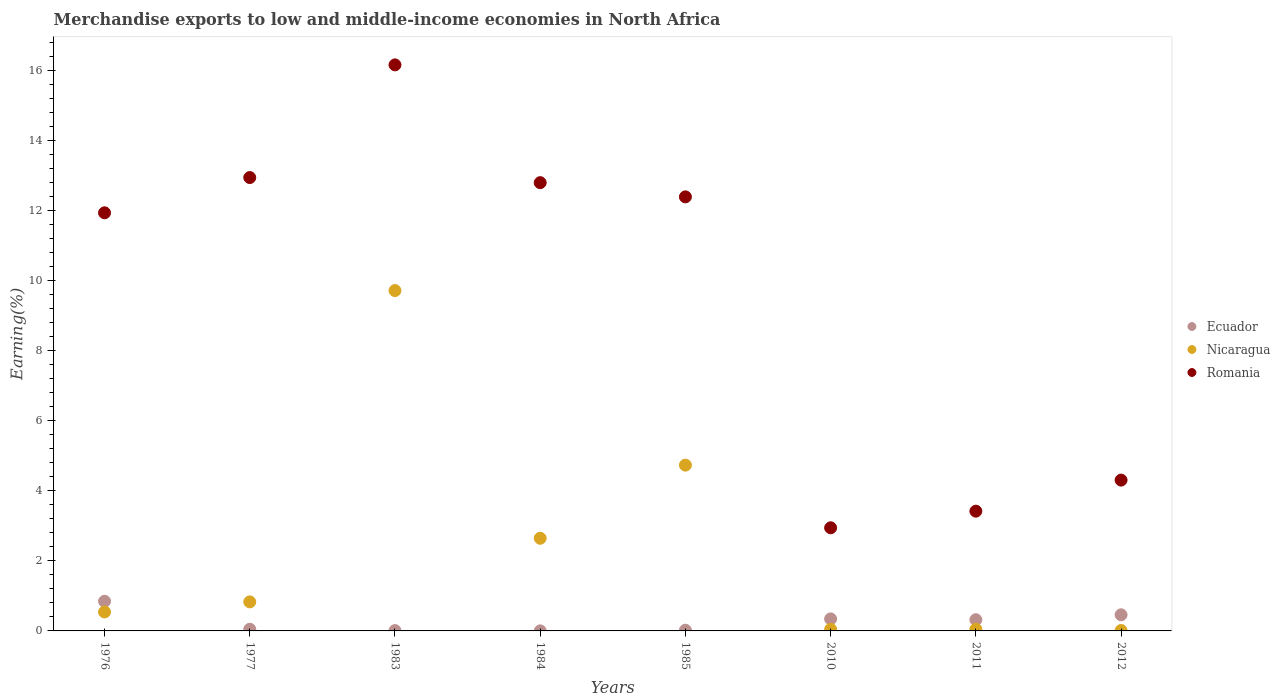What is the percentage of amount earned from merchandise exports in Nicaragua in 1983?
Offer a very short reply. 9.72. Across all years, what is the maximum percentage of amount earned from merchandise exports in Ecuador?
Make the answer very short. 0.85. Across all years, what is the minimum percentage of amount earned from merchandise exports in Ecuador?
Offer a very short reply. 0. In which year was the percentage of amount earned from merchandise exports in Nicaragua maximum?
Offer a very short reply. 1983. What is the total percentage of amount earned from merchandise exports in Romania in the graph?
Offer a terse response. 76.9. What is the difference between the percentage of amount earned from merchandise exports in Nicaragua in 1976 and that in 2012?
Your answer should be very brief. 0.53. What is the difference between the percentage of amount earned from merchandise exports in Ecuador in 1983 and the percentage of amount earned from merchandise exports in Romania in 2010?
Offer a very short reply. -2.94. What is the average percentage of amount earned from merchandise exports in Nicaragua per year?
Your answer should be compact. 2.32. In the year 1976, what is the difference between the percentage of amount earned from merchandise exports in Nicaragua and percentage of amount earned from merchandise exports in Romania?
Give a very brief answer. -11.4. What is the ratio of the percentage of amount earned from merchandise exports in Romania in 1984 to that in 2012?
Offer a very short reply. 2.97. Is the difference between the percentage of amount earned from merchandise exports in Nicaragua in 1976 and 1984 greater than the difference between the percentage of amount earned from merchandise exports in Romania in 1976 and 1984?
Make the answer very short. No. What is the difference between the highest and the second highest percentage of amount earned from merchandise exports in Romania?
Provide a short and direct response. 3.22. What is the difference between the highest and the lowest percentage of amount earned from merchandise exports in Ecuador?
Your answer should be compact. 0.84. Does the percentage of amount earned from merchandise exports in Ecuador monotonically increase over the years?
Your answer should be very brief. No. Is the percentage of amount earned from merchandise exports in Ecuador strictly greater than the percentage of amount earned from merchandise exports in Romania over the years?
Provide a succinct answer. No. Is the percentage of amount earned from merchandise exports in Ecuador strictly less than the percentage of amount earned from merchandise exports in Nicaragua over the years?
Your answer should be very brief. No. How are the legend labels stacked?
Your response must be concise. Vertical. What is the title of the graph?
Keep it short and to the point. Merchandise exports to low and middle-income economies in North Africa. Does "New Zealand" appear as one of the legend labels in the graph?
Provide a short and direct response. No. What is the label or title of the X-axis?
Ensure brevity in your answer.  Years. What is the label or title of the Y-axis?
Keep it short and to the point. Earning(%). What is the Earning(%) in Ecuador in 1976?
Your response must be concise. 0.85. What is the Earning(%) of Nicaragua in 1976?
Provide a short and direct response. 0.54. What is the Earning(%) in Romania in 1976?
Provide a succinct answer. 11.94. What is the Earning(%) in Ecuador in 1977?
Your answer should be compact. 0.05. What is the Earning(%) in Nicaragua in 1977?
Provide a succinct answer. 0.83. What is the Earning(%) in Romania in 1977?
Make the answer very short. 12.94. What is the Earning(%) of Ecuador in 1983?
Your answer should be compact. 0.01. What is the Earning(%) of Nicaragua in 1983?
Offer a terse response. 9.72. What is the Earning(%) of Romania in 1983?
Provide a short and direct response. 16.16. What is the Earning(%) of Ecuador in 1984?
Make the answer very short. 0. What is the Earning(%) of Nicaragua in 1984?
Offer a very short reply. 2.65. What is the Earning(%) of Romania in 1984?
Provide a succinct answer. 12.8. What is the Earning(%) of Ecuador in 1985?
Keep it short and to the point. 0.02. What is the Earning(%) in Nicaragua in 1985?
Offer a terse response. 4.73. What is the Earning(%) in Romania in 1985?
Provide a short and direct response. 12.39. What is the Earning(%) in Ecuador in 2010?
Give a very brief answer. 0.34. What is the Earning(%) of Nicaragua in 2010?
Your response must be concise. 0.05. What is the Earning(%) in Romania in 2010?
Offer a very short reply. 2.94. What is the Earning(%) of Ecuador in 2011?
Give a very brief answer. 0.32. What is the Earning(%) of Nicaragua in 2011?
Make the answer very short. 0.05. What is the Earning(%) in Romania in 2011?
Your answer should be very brief. 3.42. What is the Earning(%) in Ecuador in 2012?
Your response must be concise. 0.46. What is the Earning(%) of Nicaragua in 2012?
Make the answer very short. 0.01. What is the Earning(%) of Romania in 2012?
Offer a terse response. 4.31. Across all years, what is the maximum Earning(%) in Ecuador?
Your answer should be compact. 0.85. Across all years, what is the maximum Earning(%) of Nicaragua?
Your response must be concise. 9.72. Across all years, what is the maximum Earning(%) of Romania?
Offer a very short reply. 16.16. Across all years, what is the minimum Earning(%) of Ecuador?
Give a very brief answer. 0. Across all years, what is the minimum Earning(%) in Nicaragua?
Keep it short and to the point. 0.01. Across all years, what is the minimum Earning(%) in Romania?
Provide a short and direct response. 2.94. What is the total Earning(%) of Ecuador in the graph?
Provide a succinct answer. 2.05. What is the total Earning(%) in Nicaragua in the graph?
Provide a short and direct response. 18.57. What is the total Earning(%) of Romania in the graph?
Your answer should be very brief. 76.9. What is the difference between the Earning(%) of Ecuador in 1976 and that in 1977?
Your response must be concise. 0.8. What is the difference between the Earning(%) of Nicaragua in 1976 and that in 1977?
Provide a succinct answer. -0.29. What is the difference between the Earning(%) in Romania in 1976 and that in 1977?
Your answer should be compact. -1.01. What is the difference between the Earning(%) in Ecuador in 1976 and that in 1983?
Provide a succinct answer. 0.84. What is the difference between the Earning(%) of Nicaragua in 1976 and that in 1983?
Offer a very short reply. -9.18. What is the difference between the Earning(%) of Romania in 1976 and that in 1983?
Your response must be concise. -4.22. What is the difference between the Earning(%) in Ecuador in 1976 and that in 1984?
Your answer should be compact. 0.84. What is the difference between the Earning(%) of Nicaragua in 1976 and that in 1984?
Your answer should be very brief. -2.1. What is the difference between the Earning(%) in Romania in 1976 and that in 1984?
Offer a very short reply. -0.86. What is the difference between the Earning(%) of Ecuador in 1976 and that in 1985?
Your answer should be compact. 0.83. What is the difference between the Earning(%) of Nicaragua in 1976 and that in 1985?
Ensure brevity in your answer.  -4.19. What is the difference between the Earning(%) of Romania in 1976 and that in 1985?
Your response must be concise. -0.46. What is the difference between the Earning(%) in Ecuador in 1976 and that in 2010?
Provide a short and direct response. 0.5. What is the difference between the Earning(%) in Nicaragua in 1976 and that in 2010?
Your answer should be very brief. 0.5. What is the difference between the Earning(%) in Romania in 1976 and that in 2010?
Offer a very short reply. 8.99. What is the difference between the Earning(%) of Ecuador in 1976 and that in 2011?
Your answer should be compact. 0.53. What is the difference between the Earning(%) of Nicaragua in 1976 and that in 2011?
Ensure brevity in your answer.  0.49. What is the difference between the Earning(%) in Romania in 1976 and that in 2011?
Keep it short and to the point. 8.52. What is the difference between the Earning(%) of Ecuador in 1976 and that in 2012?
Give a very brief answer. 0.39. What is the difference between the Earning(%) in Nicaragua in 1976 and that in 2012?
Ensure brevity in your answer.  0.53. What is the difference between the Earning(%) in Romania in 1976 and that in 2012?
Provide a short and direct response. 7.63. What is the difference between the Earning(%) of Ecuador in 1977 and that in 1983?
Offer a terse response. 0.04. What is the difference between the Earning(%) of Nicaragua in 1977 and that in 1983?
Your answer should be very brief. -8.89. What is the difference between the Earning(%) in Romania in 1977 and that in 1983?
Make the answer very short. -3.22. What is the difference between the Earning(%) of Ecuador in 1977 and that in 1984?
Give a very brief answer. 0.05. What is the difference between the Earning(%) in Nicaragua in 1977 and that in 1984?
Ensure brevity in your answer.  -1.82. What is the difference between the Earning(%) of Romania in 1977 and that in 1984?
Give a very brief answer. 0.15. What is the difference between the Earning(%) of Ecuador in 1977 and that in 1985?
Provide a succinct answer. 0.03. What is the difference between the Earning(%) in Nicaragua in 1977 and that in 1985?
Provide a short and direct response. -3.9. What is the difference between the Earning(%) of Romania in 1977 and that in 1985?
Provide a short and direct response. 0.55. What is the difference between the Earning(%) of Ecuador in 1977 and that in 2010?
Your response must be concise. -0.29. What is the difference between the Earning(%) of Nicaragua in 1977 and that in 2010?
Your answer should be compact. 0.78. What is the difference between the Earning(%) in Romania in 1977 and that in 2010?
Provide a short and direct response. 10. What is the difference between the Earning(%) in Ecuador in 1977 and that in 2011?
Provide a succinct answer. -0.27. What is the difference between the Earning(%) in Nicaragua in 1977 and that in 2011?
Provide a short and direct response. 0.78. What is the difference between the Earning(%) of Romania in 1977 and that in 2011?
Provide a short and direct response. 9.52. What is the difference between the Earning(%) in Ecuador in 1977 and that in 2012?
Make the answer very short. -0.41. What is the difference between the Earning(%) of Nicaragua in 1977 and that in 2012?
Ensure brevity in your answer.  0.82. What is the difference between the Earning(%) of Romania in 1977 and that in 2012?
Keep it short and to the point. 8.64. What is the difference between the Earning(%) in Ecuador in 1983 and that in 1984?
Ensure brevity in your answer.  0.01. What is the difference between the Earning(%) of Nicaragua in 1983 and that in 1984?
Provide a short and direct response. 7.07. What is the difference between the Earning(%) in Romania in 1983 and that in 1984?
Ensure brevity in your answer.  3.36. What is the difference between the Earning(%) of Ecuador in 1983 and that in 1985?
Offer a terse response. -0.01. What is the difference between the Earning(%) in Nicaragua in 1983 and that in 1985?
Ensure brevity in your answer.  4.98. What is the difference between the Earning(%) in Romania in 1983 and that in 1985?
Your response must be concise. 3.77. What is the difference between the Earning(%) of Ecuador in 1983 and that in 2010?
Keep it short and to the point. -0.33. What is the difference between the Earning(%) in Nicaragua in 1983 and that in 2010?
Provide a short and direct response. 9.67. What is the difference between the Earning(%) of Romania in 1983 and that in 2010?
Provide a succinct answer. 13.22. What is the difference between the Earning(%) in Ecuador in 1983 and that in 2011?
Make the answer very short. -0.31. What is the difference between the Earning(%) of Nicaragua in 1983 and that in 2011?
Provide a succinct answer. 9.67. What is the difference between the Earning(%) in Romania in 1983 and that in 2011?
Make the answer very short. 12.74. What is the difference between the Earning(%) in Ecuador in 1983 and that in 2012?
Keep it short and to the point. -0.45. What is the difference between the Earning(%) of Nicaragua in 1983 and that in 2012?
Provide a short and direct response. 9.71. What is the difference between the Earning(%) in Romania in 1983 and that in 2012?
Ensure brevity in your answer.  11.85. What is the difference between the Earning(%) in Ecuador in 1984 and that in 1985?
Your answer should be compact. -0.02. What is the difference between the Earning(%) of Nicaragua in 1984 and that in 1985?
Ensure brevity in your answer.  -2.09. What is the difference between the Earning(%) in Romania in 1984 and that in 1985?
Offer a terse response. 0.41. What is the difference between the Earning(%) of Ecuador in 1984 and that in 2010?
Provide a short and direct response. -0.34. What is the difference between the Earning(%) of Romania in 1984 and that in 2010?
Your answer should be very brief. 9.85. What is the difference between the Earning(%) in Ecuador in 1984 and that in 2011?
Your response must be concise. -0.32. What is the difference between the Earning(%) in Nicaragua in 1984 and that in 2011?
Your response must be concise. 2.6. What is the difference between the Earning(%) in Romania in 1984 and that in 2011?
Provide a short and direct response. 9.38. What is the difference between the Earning(%) in Ecuador in 1984 and that in 2012?
Your answer should be very brief. -0.46. What is the difference between the Earning(%) of Nicaragua in 1984 and that in 2012?
Your response must be concise. 2.63. What is the difference between the Earning(%) in Romania in 1984 and that in 2012?
Provide a short and direct response. 8.49. What is the difference between the Earning(%) in Ecuador in 1985 and that in 2010?
Give a very brief answer. -0.32. What is the difference between the Earning(%) in Nicaragua in 1985 and that in 2010?
Offer a very short reply. 4.69. What is the difference between the Earning(%) in Romania in 1985 and that in 2010?
Your answer should be very brief. 9.45. What is the difference between the Earning(%) in Ecuador in 1985 and that in 2011?
Provide a short and direct response. -0.3. What is the difference between the Earning(%) in Nicaragua in 1985 and that in 2011?
Keep it short and to the point. 4.68. What is the difference between the Earning(%) in Romania in 1985 and that in 2011?
Your answer should be compact. 8.97. What is the difference between the Earning(%) in Ecuador in 1985 and that in 2012?
Your response must be concise. -0.44. What is the difference between the Earning(%) in Nicaragua in 1985 and that in 2012?
Offer a very short reply. 4.72. What is the difference between the Earning(%) of Romania in 1985 and that in 2012?
Your answer should be compact. 8.09. What is the difference between the Earning(%) of Ecuador in 2010 and that in 2011?
Make the answer very short. 0.02. What is the difference between the Earning(%) of Nicaragua in 2010 and that in 2011?
Provide a succinct answer. -0. What is the difference between the Earning(%) in Romania in 2010 and that in 2011?
Offer a terse response. -0.47. What is the difference between the Earning(%) in Ecuador in 2010 and that in 2012?
Ensure brevity in your answer.  -0.12. What is the difference between the Earning(%) in Nicaragua in 2010 and that in 2012?
Your answer should be very brief. 0.03. What is the difference between the Earning(%) in Romania in 2010 and that in 2012?
Ensure brevity in your answer.  -1.36. What is the difference between the Earning(%) in Ecuador in 2011 and that in 2012?
Offer a very short reply. -0.14. What is the difference between the Earning(%) of Nicaragua in 2011 and that in 2012?
Provide a succinct answer. 0.04. What is the difference between the Earning(%) of Romania in 2011 and that in 2012?
Your response must be concise. -0.89. What is the difference between the Earning(%) of Ecuador in 1976 and the Earning(%) of Nicaragua in 1977?
Provide a short and direct response. 0.02. What is the difference between the Earning(%) of Ecuador in 1976 and the Earning(%) of Romania in 1977?
Ensure brevity in your answer.  -12.1. What is the difference between the Earning(%) of Nicaragua in 1976 and the Earning(%) of Romania in 1977?
Offer a terse response. -12.4. What is the difference between the Earning(%) in Ecuador in 1976 and the Earning(%) in Nicaragua in 1983?
Provide a short and direct response. -8.87. What is the difference between the Earning(%) of Ecuador in 1976 and the Earning(%) of Romania in 1983?
Provide a short and direct response. -15.31. What is the difference between the Earning(%) of Nicaragua in 1976 and the Earning(%) of Romania in 1983?
Offer a terse response. -15.62. What is the difference between the Earning(%) of Ecuador in 1976 and the Earning(%) of Nicaragua in 1984?
Provide a succinct answer. -1.8. What is the difference between the Earning(%) in Ecuador in 1976 and the Earning(%) in Romania in 1984?
Offer a very short reply. -11.95. What is the difference between the Earning(%) in Nicaragua in 1976 and the Earning(%) in Romania in 1984?
Offer a very short reply. -12.26. What is the difference between the Earning(%) of Ecuador in 1976 and the Earning(%) of Nicaragua in 1985?
Your response must be concise. -3.89. What is the difference between the Earning(%) in Ecuador in 1976 and the Earning(%) in Romania in 1985?
Your response must be concise. -11.55. What is the difference between the Earning(%) in Nicaragua in 1976 and the Earning(%) in Romania in 1985?
Offer a terse response. -11.85. What is the difference between the Earning(%) in Ecuador in 1976 and the Earning(%) in Nicaragua in 2010?
Make the answer very short. 0.8. What is the difference between the Earning(%) of Ecuador in 1976 and the Earning(%) of Romania in 2010?
Provide a short and direct response. -2.1. What is the difference between the Earning(%) of Nicaragua in 1976 and the Earning(%) of Romania in 2010?
Offer a very short reply. -2.4. What is the difference between the Earning(%) of Ecuador in 1976 and the Earning(%) of Nicaragua in 2011?
Make the answer very short. 0.8. What is the difference between the Earning(%) in Ecuador in 1976 and the Earning(%) in Romania in 2011?
Your answer should be compact. -2.57. What is the difference between the Earning(%) in Nicaragua in 1976 and the Earning(%) in Romania in 2011?
Your answer should be compact. -2.88. What is the difference between the Earning(%) of Ecuador in 1976 and the Earning(%) of Nicaragua in 2012?
Give a very brief answer. 0.83. What is the difference between the Earning(%) of Ecuador in 1976 and the Earning(%) of Romania in 2012?
Offer a terse response. -3.46. What is the difference between the Earning(%) in Nicaragua in 1976 and the Earning(%) in Romania in 2012?
Provide a short and direct response. -3.76. What is the difference between the Earning(%) of Ecuador in 1977 and the Earning(%) of Nicaragua in 1983?
Offer a terse response. -9.67. What is the difference between the Earning(%) in Ecuador in 1977 and the Earning(%) in Romania in 1983?
Provide a succinct answer. -16.11. What is the difference between the Earning(%) of Nicaragua in 1977 and the Earning(%) of Romania in 1983?
Offer a very short reply. -15.33. What is the difference between the Earning(%) in Ecuador in 1977 and the Earning(%) in Nicaragua in 1984?
Provide a succinct answer. -2.6. What is the difference between the Earning(%) of Ecuador in 1977 and the Earning(%) of Romania in 1984?
Your response must be concise. -12.75. What is the difference between the Earning(%) of Nicaragua in 1977 and the Earning(%) of Romania in 1984?
Ensure brevity in your answer.  -11.97. What is the difference between the Earning(%) in Ecuador in 1977 and the Earning(%) in Nicaragua in 1985?
Your response must be concise. -4.68. What is the difference between the Earning(%) in Ecuador in 1977 and the Earning(%) in Romania in 1985?
Give a very brief answer. -12.34. What is the difference between the Earning(%) of Nicaragua in 1977 and the Earning(%) of Romania in 1985?
Ensure brevity in your answer.  -11.56. What is the difference between the Earning(%) in Ecuador in 1977 and the Earning(%) in Nicaragua in 2010?
Offer a terse response. 0. What is the difference between the Earning(%) of Ecuador in 1977 and the Earning(%) of Romania in 2010?
Provide a short and direct response. -2.9. What is the difference between the Earning(%) of Nicaragua in 1977 and the Earning(%) of Romania in 2010?
Provide a short and direct response. -2.12. What is the difference between the Earning(%) of Ecuador in 1977 and the Earning(%) of Nicaragua in 2011?
Make the answer very short. -0. What is the difference between the Earning(%) in Ecuador in 1977 and the Earning(%) in Romania in 2011?
Make the answer very short. -3.37. What is the difference between the Earning(%) in Nicaragua in 1977 and the Earning(%) in Romania in 2011?
Your answer should be very brief. -2.59. What is the difference between the Earning(%) of Ecuador in 1977 and the Earning(%) of Nicaragua in 2012?
Offer a very short reply. 0.04. What is the difference between the Earning(%) in Ecuador in 1977 and the Earning(%) in Romania in 2012?
Your response must be concise. -4.26. What is the difference between the Earning(%) of Nicaragua in 1977 and the Earning(%) of Romania in 2012?
Give a very brief answer. -3.48. What is the difference between the Earning(%) of Ecuador in 1983 and the Earning(%) of Nicaragua in 1984?
Provide a succinct answer. -2.64. What is the difference between the Earning(%) of Ecuador in 1983 and the Earning(%) of Romania in 1984?
Give a very brief answer. -12.79. What is the difference between the Earning(%) of Nicaragua in 1983 and the Earning(%) of Romania in 1984?
Your response must be concise. -3.08. What is the difference between the Earning(%) in Ecuador in 1983 and the Earning(%) in Nicaragua in 1985?
Keep it short and to the point. -4.72. What is the difference between the Earning(%) of Ecuador in 1983 and the Earning(%) of Romania in 1985?
Offer a terse response. -12.38. What is the difference between the Earning(%) of Nicaragua in 1983 and the Earning(%) of Romania in 1985?
Your response must be concise. -2.68. What is the difference between the Earning(%) of Ecuador in 1983 and the Earning(%) of Nicaragua in 2010?
Offer a terse response. -0.04. What is the difference between the Earning(%) in Ecuador in 1983 and the Earning(%) in Romania in 2010?
Ensure brevity in your answer.  -2.94. What is the difference between the Earning(%) in Nicaragua in 1983 and the Earning(%) in Romania in 2010?
Make the answer very short. 6.77. What is the difference between the Earning(%) of Ecuador in 1983 and the Earning(%) of Nicaragua in 2011?
Offer a very short reply. -0.04. What is the difference between the Earning(%) in Ecuador in 1983 and the Earning(%) in Romania in 2011?
Your response must be concise. -3.41. What is the difference between the Earning(%) in Nicaragua in 1983 and the Earning(%) in Romania in 2011?
Offer a terse response. 6.3. What is the difference between the Earning(%) in Ecuador in 1983 and the Earning(%) in Nicaragua in 2012?
Your response must be concise. -0. What is the difference between the Earning(%) of Ecuador in 1983 and the Earning(%) of Romania in 2012?
Your answer should be compact. -4.3. What is the difference between the Earning(%) of Nicaragua in 1983 and the Earning(%) of Romania in 2012?
Offer a very short reply. 5.41. What is the difference between the Earning(%) of Ecuador in 1984 and the Earning(%) of Nicaragua in 1985?
Give a very brief answer. -4.73. What is the difference between the Earning(%) of Ecuador in 1984 and the Earning(%) of Romania in 1985?
Your response must be concise. -12.39. What is the difference between the Earning(%) in Nicaragua in 1984 and the Earning(%) in Romania in 1985?
Your response must be concise. -9.75. What is the difference between the Earning(%) of Ecuador in 1984 and the Earning(%) of Nicaragua in 2010?
Give a very brief answer. -0.04. What is the difference between the Earning(%) in Ecuador in 1984 and the Earning(%) in Romania in 2010?
Offer a terse response. -2.94. What is the difference between the Earning(%) in Nicaragua in 1984 and the Earning(%) in Romania in 2010?
Offer a terse response. -0.3. What is the difference between the Earning(%) of Ecuador in 1984 and the Earning(%) of Nicaragua in 2011?
Offer a terse response. -0.05. What is the difference between the Earning(%) of Ecuador in 1984 and the Earning(%) of Romania in 2011?
Offer a very short reply. -3.42. What is the difference between the Earning(%) of Nicaragua in 1984 and the Earning(%) of Romania in 2011?
Ensure brevity in your answer.  -0.77. What is the difference between the Earning(%) in Ecuador in 1984 and the Earning(%) in Nicaragua in 2012?
Keep it short and to the point. -0.01. What is the difference between the Earning(%) of Ecuador in 1984 and the Earning(%) of Romania in 2012?
Your response must be concise. -4.3. What is the difference between the Earning(%) in Nicaragua in 1984 and the Earning(%) in Romania in 2012?
Offer a terse response. -1.66. What is the difference between the Earning(%) of Ecuador in 1985 and the Earning(%) of Nicaragua in 2010?
Provide a short and direct response. -0.03. What is the difference between the Earning(%) of Ecuador in 1985 and the Earning(%) of Romania in 2010?
Make the answer very short. -2.92. What is the difference between the Earning(%) of Nicaragua in 1985 and the Earning(%) of Romania in 2010?
Keep it short and to the point. 1.79. What is the difference between the Earning(%) in Ecuador in 1985 and the Earning(%) in Nicaragua in 2011?
Make the answer very short. -0.03. What is the difference between the Earning(%) of Ecuador in 1985 and the Earning(%) of Romania in 2011?
Your answer should be very brief. -3.4. What is the difference between the Earning(%) of Nicaragua in 1985 and the Earning(%) of Romania in 2011?
Ensure brevity in your answer.  1.31. What is the difference between the Earning(%) of Ecuador in 1985 and the Earning(%) of Nicaragua in 2012?
Your answer should be compact. 0.01. What is the difference between the Earning(%) of Ecuador in 1985 and the Earning(%) of Romania in 2012?
Ensure brevity in your answer.  -4.29. What is the difference between the Earning(%) of Nicaragua in 1985 and the Earning(%) of Romania in 2012?
Your answer should be compact. 0.43. What is the difference between the Earning(%) in Ecuador in 2010 and the Earning(%) in Nicaragua in 2011?
Make the answer very short. 0.29. What is the difference between the Earning(%) in Ecuador in 2010 and the Earning(%) in Romania in 2011?
Keep it short and to the point. -3.08. What is the difference between the Earning(%) in Nicaragua in 2010 and the Earning(%) in Romania in 2011?
Give a very brief answer. -3.37. What is the difference between the Earning(%) in Ecuador in 2010 and the Earning(%) in Nicaragua in 2012?
Provide a succinct answer. 0.33. What is the difference between the Earning(%) of Ecuador in 2010 and the Earning(%) of Romania in 2012?
Your answer should be compact. -3.96. What is the difference between the Earning(%) of Nicaragua in 2010 and the Earning(%) of Romania in 2012?
Your answer should be very brief. -4.26. What is the difference between the Earning(%) in Ecuador in 2011 and the Earning(%) in Nicaragua in 2012?
Offer a very short reply. 0.31. What is the difference between the Earning(%) of Ecuador in 2011 and the Earning(%) of Romania in 2012?
Provide a succinct answer. -3.99. What is the difference between the Earning(%) of Nicaragua in 2011 and the Earning(%) of Romania in 2012?
Offer a very short reply. -4.26. What is the average Earning(%) in Ecuador per year?
Offer a terse response. 0.26. What is the average Earning(%) of Nicaragua per year?
Provide a succinct answer. 2.32. What is the average Earning(%) of Romania per year?
Your answer should be compact. 9.61. In the year 1976, what is the difference between the Earning(%) in Ecuador and Earning(%) in Nicaragua?
Provide a succinct answer. 0.3. In the year 1976, what is the difference between the Earning(%) in Ecuador and Earning(%) in Romania?
Offer a very short reply. -11.09. In the year 1976, what is the difference between the Earning(%) of Nicaragua and Earning(%) of Romania?
Your response must be concise. -11.4. In the year 1977, what is the difference between the Earning(%) of Ecuador and Earning(%) of Nicaragua?
Your answer should be compact. -0.78. In the year 1977, what is the difference between the Earning(%) of Ecuador and Earning(%) of Romania?
Offer a very short reply. -12.9. In the year 1977, what is the difference between the Earning(%) in Nicaragua and Earning(%) in Romania?
Offer a very short reply. -12.11. In the year 1983, what is the difference between the Earning(%) of Ecuador and Earning(%) of Nicaragua?
Ensure brevity in your answer.  -9.71. In the year 1983, what is the difference between the Earning(%) of Ecuador and Earning(%) of Romania?
Give a very brief answer. -16.15. In the year 1983, what is the difference between the Earning(%) in Nicaragua and Earning(%) in Romania?
Provide a short and direct response. -6.44. In the year 1984, what is the difference between the Earning(%) of Ecuador and Earning(%) of Nicaragua?
Your answer should be compact. -2.64. In the year 1984, what is the difference between the Earning(%) in Ecuador and Earning(%) in Romania?
Your response must be concise. -12.8. In the year 1984, what is the difference between the Earning(%) in Nicaragua and Earning(%) in Romania?
Ensure brevity in your answer.  -10.15. In the year 1985, what is the difference between the Earning(%) in Ecuador and Earning(%) in Nicaragua?
Provide a succinct answer. -4.71. In the year 1985, what is the difference between the Earning(%) in Ecuador and Earning(%) in Romania?
Give a very brief answer. -12.37. In the year 1985, what is the difference between the Earning(%) in Nicaragua and Earning(%) in Romania?
Give a very brief answer. -7.66. In the year 2010, what is the difference between the Earning(%) of Ecuador and Earning(%) of Nicaragua?
Keep it short and to the point. 0.3. In the year 2010, what is the difference between the Earning(%) in Ecuador and Earning(%) in Romania?
Your response must be concise. -2.6. In the year 2010, what is the difference between the Earning(%) in Nicaragua and Earning(%) in Romania?
Your answer should be very brief. -2.9. In the year 2011, what is the difference between the Earning(%) of Ecuador and Earning(%) of Nicaragua?
Make the answer very short. 0.27. In the year 2011, what is the difference between the Earning(%) of Ecuador and Earning(%) of Romania?
Offer a terse response. -3.1. In the year 2011, what is the difference between the Earning(%) of Nicaragua and Earning(%) of Romania?
Your answer should be compact. -3.37. In the year 2012, what is the difference between the Earning(%) in Ecuador and Earning(%) in Nicaragua?
Your answer should be very brief. 0.45. In the year 2012, what is the difference between the Earning(%) of Ecuador and Earning(%) of Romania?
Provide a succinct answer. -3.85. In the year 2012, what is the difference between the Earning(%) in Nicaragua and Earning(%) in Romania?
Give a very brief answer. -4.29. What is the ratio of the Earning(%) in Ecuador in 1976 to that in 1977?
Provide a short and direct response. 17.41. What is the ratio of the Earning(%) in Nicaragua in 1976 to that in 1977?
Ensure brevity in your answer.  0.65. What is the ratio of the Earning(%) of Romania in 1976 to that in 1977?
Offer a terse response. 0.92. What is the ratio of the Earning(%) in Ecuador in 1976 to that in 1983?
Ensure brevity in your answer.  94.26. What is the ratio of the Earning(%) in Nicaragua in 1976 to that in 1983?
Your response must be concise. 0.06. What is the ratio of the Earning(%) in Romania in 1976 to that in 1983?
Your response must be concise. 0.74. What is the ratio of the Earning(%) in Ecuador in 1976 to that in 1984?
Ensure brevity in your answer.  545.93. What is the ratio of the Earning(%) in Nicaragua in 1976 to that in 1984?
Your answer should be compact. 0.2. What is the ratio of the Earning(%) of Romania in 1976 to that in 1984?
Your response must be concise. 0.93. What is the ratio of the Earning(%) in Ecuador in 1976 to that in 1985?
Ensure brevity in your answer.  43.14. What is the ratio of the Earning(%) of Nicaragua in 1976 to that in 1985?
Ensure brevity in your answer.  0.11. What is the ratio of the Earning(%) in Romania in 1976 to that in 1985?
Your answer should be very brief. 0.96. What is the ratio of the Earning(%) in Ecuador in 1976 to that in 2010?
Keep it short and to the point. 2.47. What is the ratio of the Earning(%) of Nicaragua in 1976 to that in 2010?
Keep it short and to the point. 11.88. What is the ratio of the Earning(%) of Romania in 1976 to that in 2010?
Your answer should be very brief. 4.05. What is the ratio of the Earning(%) of Ecuador in 1976 to that in 2011?
Ensure brevity in your answer.  2.64. What is the ratio of the Earning(%) of Nicaragua in 1976 to that in 2011?
Keep it short and to the point. 11.06. What is the ratio of the Earning(%) in Romania in 1976 to that in 2011?
Make the answer very short. 3.49. What is the ratio of the Earning(%) of Ecuador in 1976 to that in 2012?
Offer a terse response. 1.84. What is the ratio of the Earning(%) of Nicaragua in 1976 to that in 2012?
Make the answer very short. 46.39. What is the ratio of the Earning(%) of Romania in 1976 to that in 2012?
Provide a short and direct response. 2.77. What is the ratio of the Earning(%) in Ecuador in 1977 to that in 1983?
Provide a succinct answer. 5.41. What is the ratio of the Earning(%) of Nicaragua in 1977 to that in 1983?
Your response must be concise. 0.09. What is the ratio of the Earning(%) of Romania in 1977 to that in 1983?
Offer a terse response. 0.8. What is the ratio of the Earning(%) in Ecuador in 1977 to that in 1984?
Your response must be concise. 31.36. What is the ratio of the Earning(%) in Nicaragua in 1977 to that in 1984?
Ensure brevity in your answer.  0.31. What is the ratio of the Earning(%) in Romania in 1977 to that in 1984?
Your answer should be compact. 1.01. What is the ratio of the Earning(%) of Ecuador in 1977 to that in 1985?
Give a very brief answer. 2.48. What is the ratio of the Earning(%) in Nicaragua in 1977 to that in 1985?
Ensure brevity in your answer.  0.18. What is the ratio of the Earning(%) of Romania in 1977 to that in 1985?
Your response must be concise. 1.04. What is the ratio of the Earning(%) in Ecuador in 1977 to that in 2010?
Give a very brief answer. 0.14. What is the ratio of the Earning(%) in Nicaragua in 1977 to that in 2010?
Your response must be concise. 18.19. What is the ratio of the Earning(%) in Romania in 1977 to that in 2010?
Ensure brevity in your answer.  4.4. What is the ratio of the Earning(%) in Ecuador in 1977 to that in 2011?
Make the answer very short. 0.15. What is the ratio of the Earning(%) of Nicaragua in 1977 to that in 2011?
Provide a short and direct response. 16.93. What is the ratio of the Earning(%) of Romania in 1977 to that in 2011?
Offer a terse response. 3.79. What is the ratio of the Earning(%) in Ecuador in 1977 to that in 2012?
Provide a short and direct response. 0.11. What is the ratio of the Earning(%) of Nicaragua in 1977 to that in 2012?
Give a very brief answer. 71.03. What is the ratio of the Earning(%) of Romania in 1977 to that in 2012?
Give a very brief answer. 3.01. What is the ratio of the Earning(%) of Ecuador in 1983 to that in 1984?
Your answer should be very brief. 5.79. What is the ratio of the Earning(%) of Nicaragua in 1983 to that in 1984?
Offer a terse response. 3.67. What is the ratio of the Earning(%) in Romania in 1983 to that in 1984?
Make the answer very short. 1.26. What is the ratio of the Earning(%) of Ecuador in 1983 to that in 1985?
Provide a short and direct response. 0.46. What is the ratio of the Earning(%) of Nicaragua in 1983 to that in 1985?
Your answer should be very brief. 2.05. What is the ratio of the Earning(%) of Romania in 1983 to that in 1985?
Provide a short and direct response. 1.3. What is the ratio of the Earning(%) in Ecuador in 1983 to that in 2010?
Your answer should be compact. 0.03. What is the ratio of the Earning(%) in Nicaragua in 1983 to that in 2010?
Ensure brevity in your answer.  213.18. What is the ratio of the Earning(%) in Romania in 1983 to that in 2010?
Give a very brief answer. 5.49. What is the ratio of the Earning(%) of Ecuador in 1983 to that in 2011?
Give a very brief answer. 0.03. What is the ratio of the Earning(%) of Nicaragua in 1983 to that in 2011?
Provide a short and direct response. 198.42. What is the ratio of the Earning(%) of Romania in 1983 to that in 2011?
Provide a short and direct response. 4.73. What is the ratio of the Earning(%) in Ecuador in 1983 to that in 2012?
Make the answer very short. 0.02. What is the ratio of the Earning(%) in Nicaragua in 1983 to that in 2012?
Provide a short and direct response. 832.39. What is the ratio of the Earning(%) of Romania in 1983 to that in 2012?
Your response must be concise. 3.75. What is the ratio of the Earning(%) of Ecuador in 1984 to that in 1985?
Give a very brief answer. 0.08. What is the ratio of the Earning(%) of Nicaragua in 1984 to that in 1985?
Provide a succinct answer. 0.56. What is the ratio of the Earning(%) in Romania in 1984 to that in 1985?
Provide a succinct answer. 1.03. What is the ratio of the Earning(%) of Ecuador in 1984 to that in 2010?
Ensure brevity in your answer.  0. What is the ratio of the Earning(%) in Nicaragua in 1984 to that in 2010?
Give a very brief answer. 58.04. What is the ratio of the Earning(%) in Romania in 1984 to that in 2010?
Make the answer very short. 4.35. What is the ratio of the Earning(%) in Ecuador in 1984 to that in 2011?
Give a very brief answer. 0. What is the ratio of the Earning(%) of Nicaragua in 1984 to that in 2011?
Keep it short and to the point. 54.02. What is the ratio of the Earning(%) in Romania in 1984 to that in 2011?
Your answer should be compact. 3.74. What is the ratio of the Earning(%) in Ecuador in 1984 to that in 2012?
Provide a succinct answer. 0. What is the ratio of the Earning(%) of Nicaragua in 1984 to that in 2012?
Your response must be concise. 226.63. What is the ratio of the Earning(%) of Romania in 1984 to that in 2012?
Your answer should be compact. 2.97. What is the ratio of the Earning(%) of Ecuador in 1985 to that in 2010?
Your response must be concise. 0.06. What is the ratio of the Earning(%) of Nicaragua in 1985 to that in 2010?
Ensure brevity in your answer.  103.85. What is the ratio of the Earning(%) in Romania in 1985 to that in 2010?
Offer a terse response. 4.21. What is the ratio of the Earning(%) in Ecuador in 1985 to that in 2011?
Make the answer very short. 0.06. What is the ratio of the Earning(%) of Nicaragua in 1985 to that in 2011?
Your response must be concise. 96.65. What is the ratio of the Earning(%) of Romania in 1985 to that in 2011?
Offer a very short reply. 3.62. What is the ratio of the Earning(%) of Ecuador in 1985 to that in 2012?
Provide a short and direct response. 0.04. What is the ratio of the Earning(%) of Nicaragua in 1985 to that in 2012?
Provide a succinct answer. 405.47. What is the ratio of the Earning(%) in Romania in 1985 to that in 2012?
Your answer should be compact. 2.88. What is the ratio of the Earning(%) of Ecuador in 2010 to that in 2011?
Offer a very short reply. 1.07. What is the ratio of the Earning(%) of Nicaragua in 2010 to that in 2011?
Make the answer very short. 0.93. What is the ratio of the Earning(%) in Romania in 2010 to that in 2011?
Ensure brevity in your answer.  0.86. What is the ratio of the Earning(%) in Ecuador in 2010 to that in 2012?
Offer a very short reply. 0.75. What is the ratio of the Earning(%) of Nicaragua in 2010 to that in 2012?
Offer a very short reply. 3.9. What is the ratio of the Earning(%) of Romania in 2010 to that in 2012?
Your response must be concise. 0.68. What is the ratio of the Earning(%) in Ecuador in 2011 to that in 2012?
Offer a terse response. 0.7. What is the ratio of the Earning(%) of Nicaragua in 2011 to that in 2012?
Ensure brevity in your answer.  4.2. What is the ratio of the Earning(%) of Romania in 2011 to that in 2012?
Ensure brevity in your answer.  0.79. What is the difference between the highest and the second highest Earning(%) of Ecuador?
Your answer should be very brief. 0.39. What is the difference between the highest and the second highest Earning(%) in Nicaragua?
Your answer should be very brief. 4.98. What is the difference between the highest and the second highest Earning(%) in Romania?
Offer a very short reply. 3.22. What is the difference between the highest and the lowest Earning(%) in Ecuador?
Your answer should be compact. 0.84. What is the difference between the highest and the lowest Earning(%) of Nicaragua?
Provide a succinct answer. 9.71. What is the difference between the highest and the lowest Earning(%) in Romania?
Offer a terse response. 13.22. 